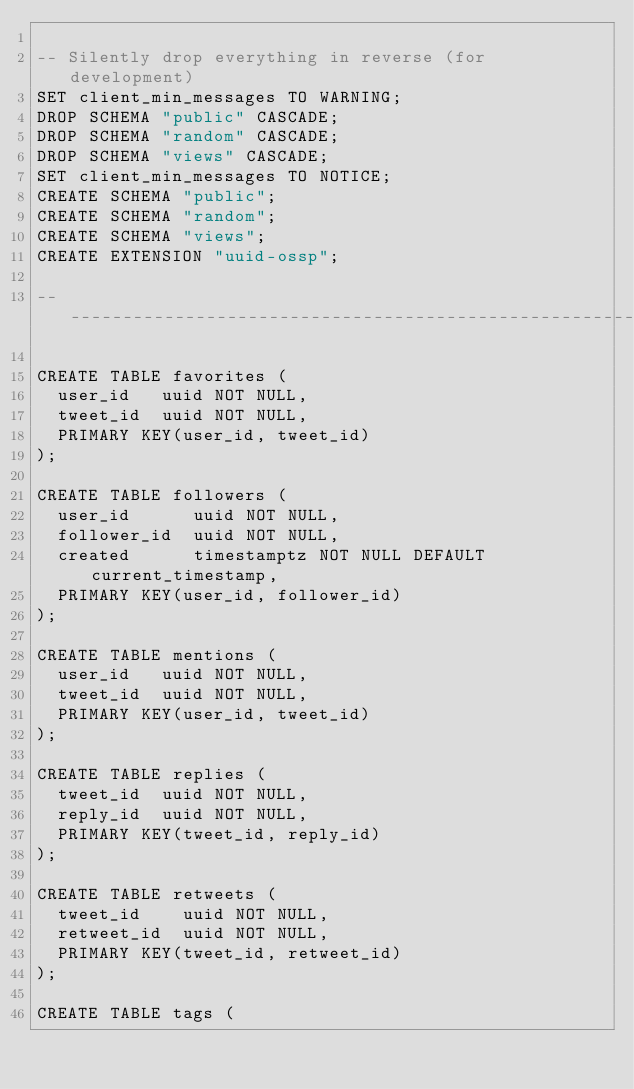<code> <loc_0><loc_0><loc_500><loc_500><_SQL_>
-- Silently drop everything in reverse (for development)
SET client_min_messages TO WARNING;
DROP SCHEMA "public" CASCADE;
DROP SCHEMA "random" CASCADE;
DROP SCHEMA "views" CASCADE;
SET client_min_messages TO NOTICE;
CREATE SCHEMA "public";
CREATE SCHEMA "random";
CREATE SCHEMA "views";
CREATE EXTENSION "uuid-ossp";

-------------------------------------------------------------------------------

CREATE TABLE favorites (
  user_id   uuid NOT NULL,
  tweet_id  uuid NOT NULL,
  PRIMARY KEY(user_id, tweet_id)
);

CREATE TABLE followers (
  user_id      uuid NOT NULL,
  follower_id  uuid NOT NULL, 
  created      timestamptz NOT NULL DEFAULT current_timestamp,
  PRIMARY KEY(user_id, follower_id)
);

CREATE TABLE mentions (
  user_id   uuid NOT NULL,
  tweet_id  uuid NOT NULL,  
  PRIMARY KEY(user_id, tweet_id)
);

CREATE TABLE replies (
  tweet_id  uuid NOT NULL,
  reply_id  uuid NOT NULL,
  PRIMARY KEY(tweet_id, reply_id)
);

CREATE TABLE retweets (
  tweet_id    uuid NOT NULL,
  retweet_id  uuid NOT NULL,
  PRIMARY KEY(tweet_id, retweet_id)
);

CREATE TABLE tags (</code> 